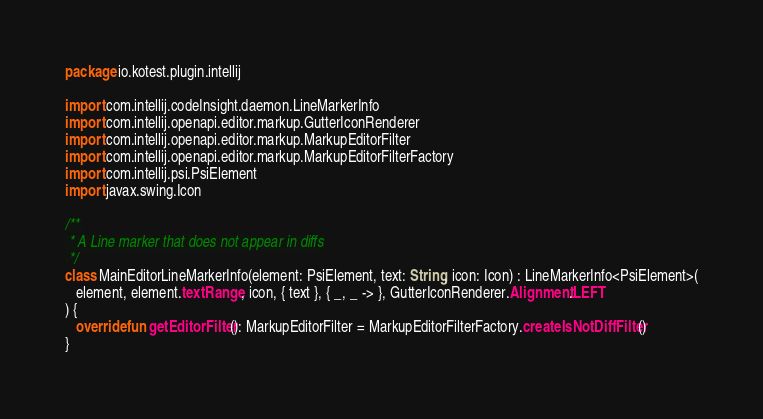<code> <loc_0><loc_0><loc_500><loc_500><_Kotlin_>package io.kotest.plugin.intellij

import com.intellij.codeInsight.daemon.LineMarkerInfo
import com.intellij.openapi.editor.markup.GutterIconRenderer
import com.intellij.openapi.editor.markup.MarkupEditorFilter
import com.intellij.openapi.editor.markup.MarkupEditorFilterFactory
import com.intellij.psi.PsiElement
import javax.swing.Icon

/**
 * A Line marker that does not appear in diffs
 */
class MainEditorLineMarkerInfo(element: PsiElement, text: String, icon: Icon) : LineMarkerInfo<PsiElement>(
   element, element.textRange, icon, { text }, { _, _ -> }, GutterIconRenderer.Alignment.LEFT
) {
   override fun getEditorFilter(): MarkupEditorFilter = MarkupEditorFilterFactory.createIsNotDiffFilter()
}
</code> 